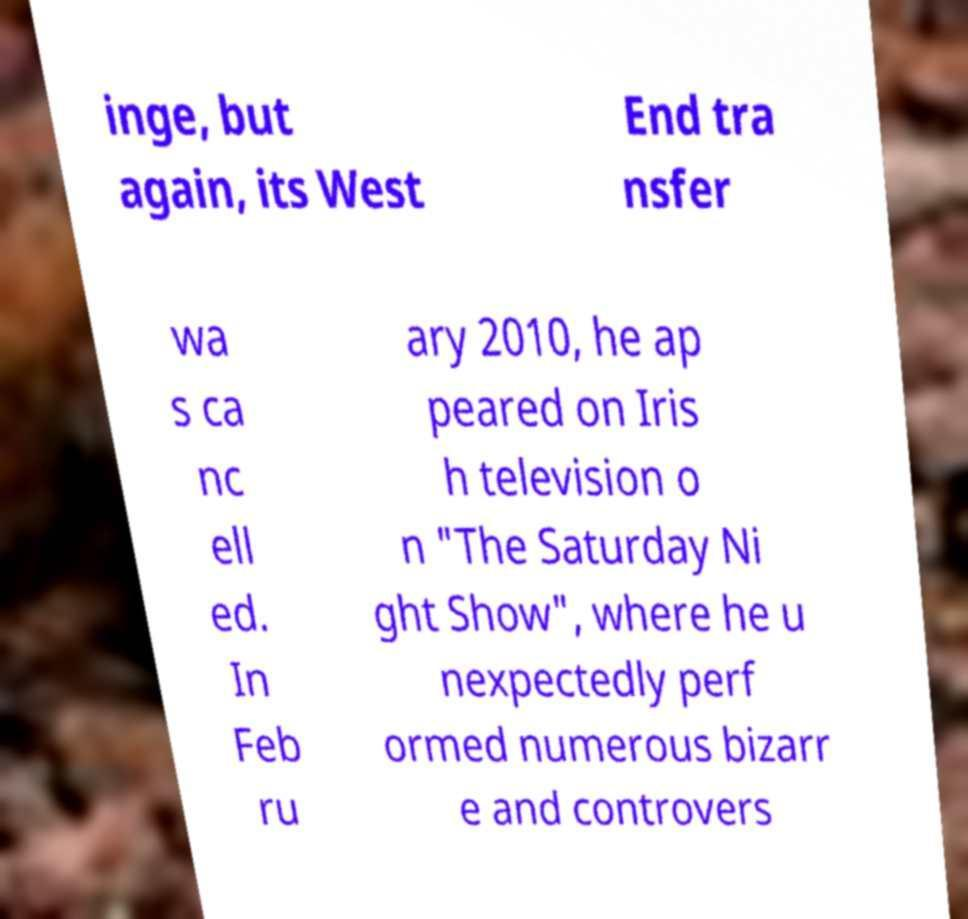Could you extract and type out the text from this image? inge, but again, its West End tra nsfer wa s ca nc ell ed. In Feb ru ary 2010, he ap peared on Iris h television o n "The Saturday Ni ght Show", where he u nexpectedly perf ormed numerous bizarr e and controvers 